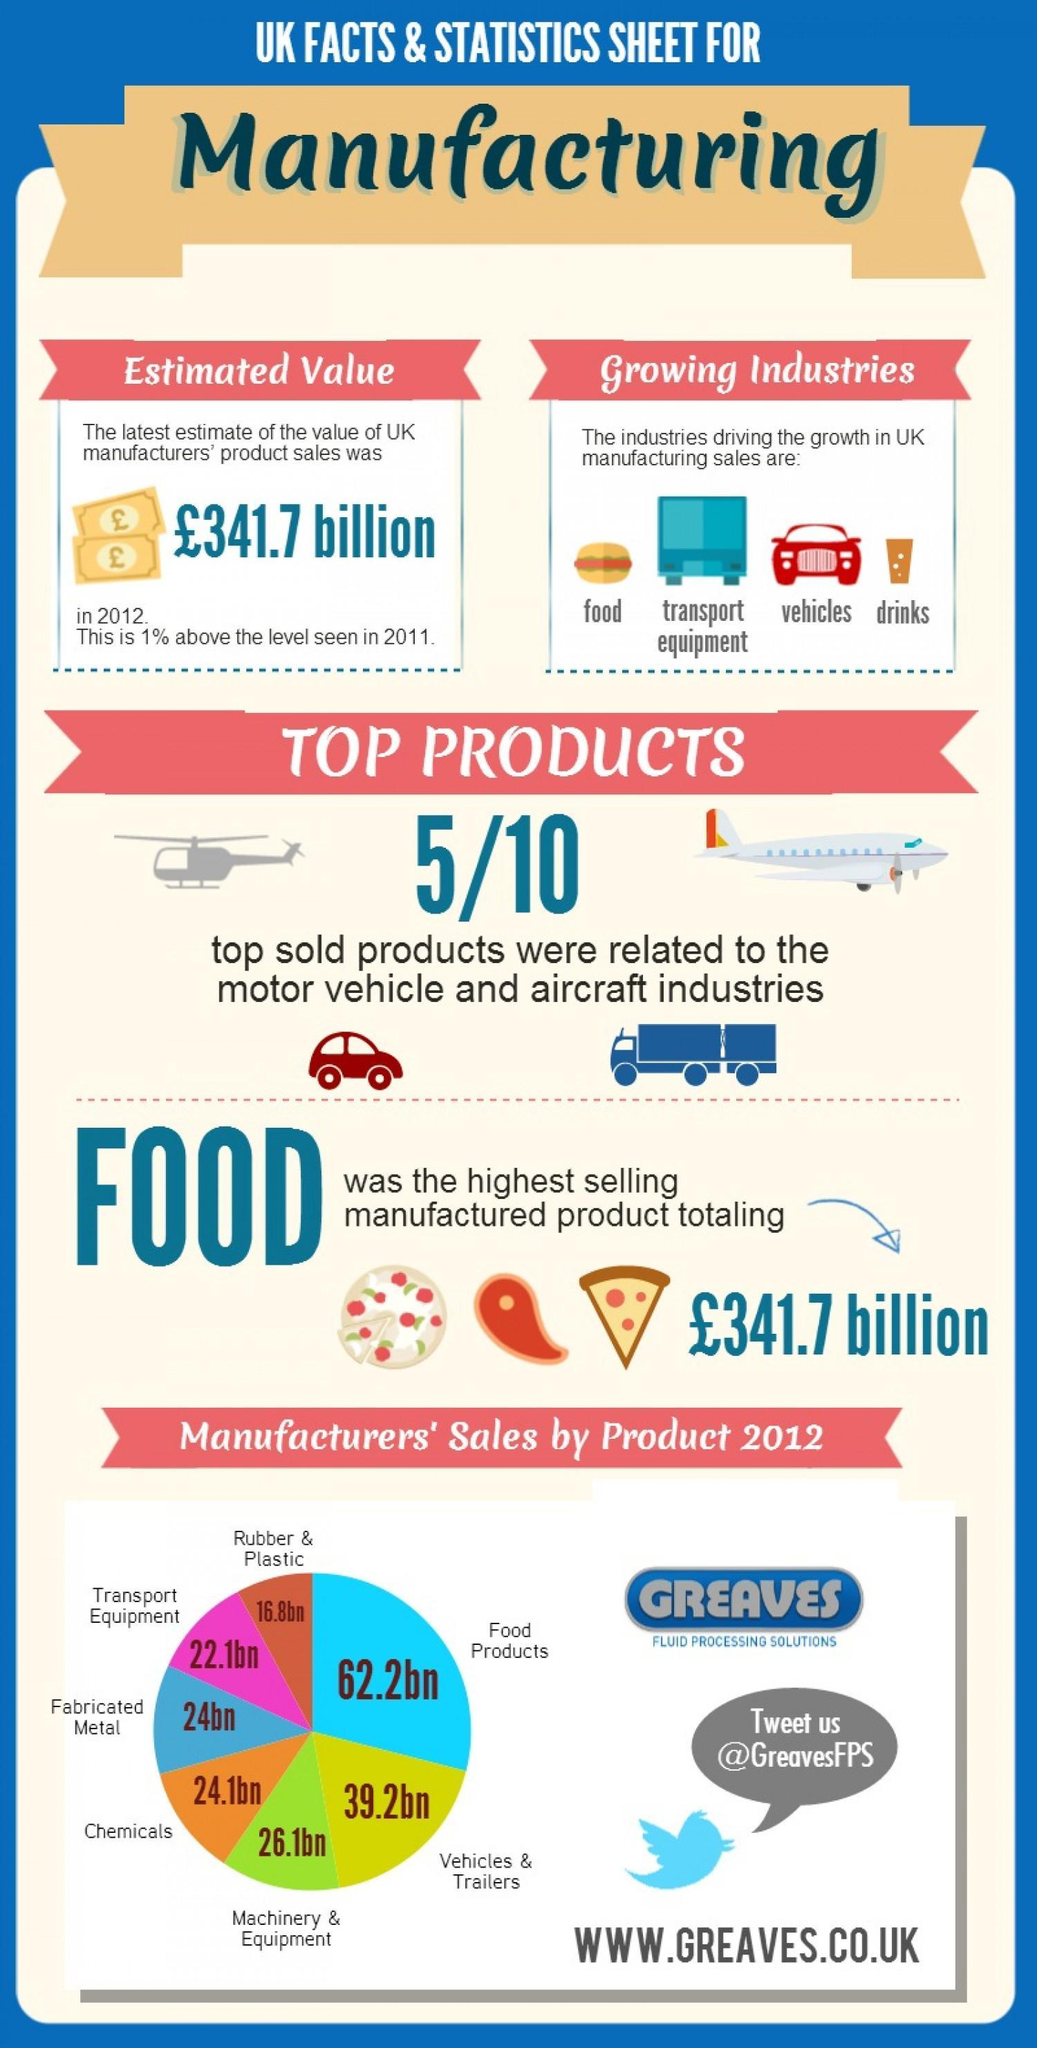What is the estimated value at which Fabricated Metal was manufactured in the UK?
Answer the question with a short phrase. 24bn Which is the highest selling manufactured product in the UK? Food Which is the third highest selling manufactured product in the UK? Machinery & Equipment Which is the second highest selling manufactured product in the UK? Vehicles & Trailers What is the estimated value at which Machinery & Equipment was manufactured in the UK? 26.1bn What is the estimated value at which Chemicals was manufactured in the UK? 24.1bn What is the estimated value at which Food was manufactured in the UK? £341.7 Billion What is the estimated value at which Transport Equipment was manufactured in the UK? 22.1bn What is the estimated value at which Rubber & Plastic was manufactured in the UK? 16.8bn What is the estimated value at which Vehicles & Trailers was manufactured in the UK? 39.2bn 